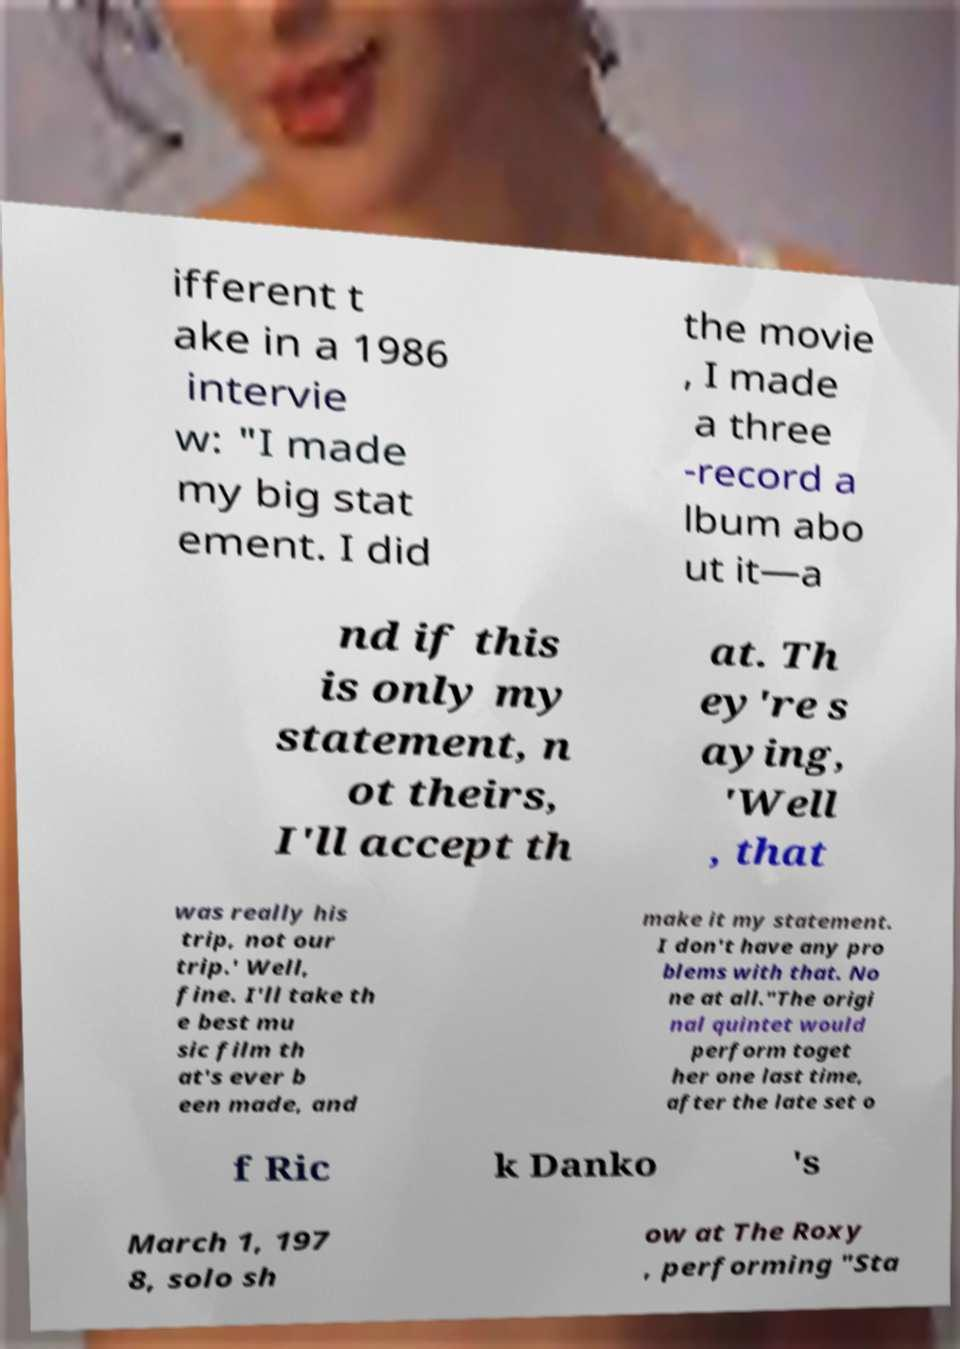Could you assist in decoding the text presented in this image and type it out clearly? ifferent t ake in a 1986 intervie w: "I made my big stat ement. I did the movie , I made a three -record a lbum abo ut it—a nd if this is only my statement, n ot theirs, I'll accept th at. Th ey're s aying, 'Well , that was really his trip, not our trip.' Well, fine. I'll take th e best mu sic film th at's ever b een made, and make it my statement. I don't have any pro blems with that. No ne at all."The origi nal quintet would perform toget her one last time, after the late set o f Ric k Danko 's March 1, 197 8, solo sh ow at The Roxy , performing "Sta 